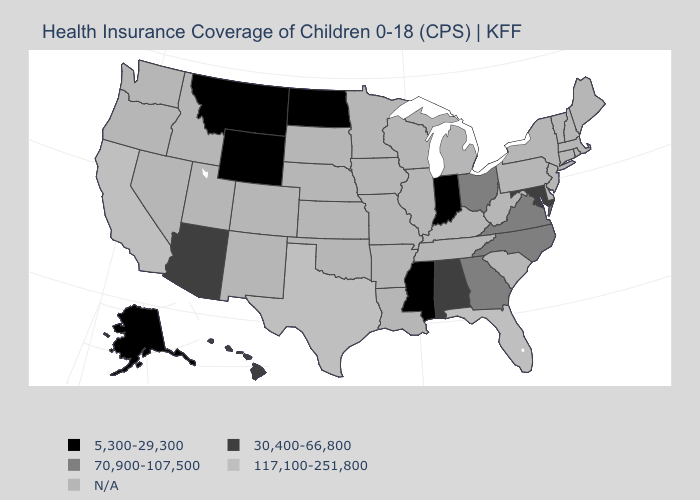What is the value of New Jersey?
Short answer required. N/A. What is the value of Indiana?
Be succinct. 5,300-29,300. Name the states that have a value in the range 5,300-29,300?
Answer briefly. Alaska, Indiana, Mississippi, Montana, North Dakota, Wyoming. What is the lowest value in the West?
Concise answer only. 5,300-29,300. What is the value of Kentucky?
Short answer required. N/A. What is the highest value in the MidWest ?
Answer briefly. 70,900-107,500. Name the states that have a value in the range 70,900-107,500?
Short answer required. Georgia, North Carolina, Ohio, Virginia. Does the first symbol in the legend represent the smallest category?
Keep it brief. Yes. What is the value of Rhode Island?
Keep it brief. N/A. What is the value of Wisconsin?
Keep it brief. N/A. Is the legend a continuous bar?
Be succinct. No. What is the highest value in states that border New Mexico?
Short answer required. 117,100-251,800. Name the states that have a value in the range 70,900-107,500?
Keep it brief. Georgia, North Carolina, Ohio, Virginia. 